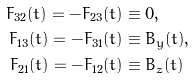<formula> <loc_0><loc_0><loc_500><loc_500>F _ { 3 2 } ( t ) = - F _ { 2 3 } ( t ) & \equiv 0 , \\ F _ { 1 3 } ( t ) = - F _ { 3 1 } ( t ) & \equiv B _ { y } ( t ) , \\ F _ { 2 1 } ( t ) = - F _ { 1 2 } ( t ) & \equiv B _ { z } ( t )</formula> 